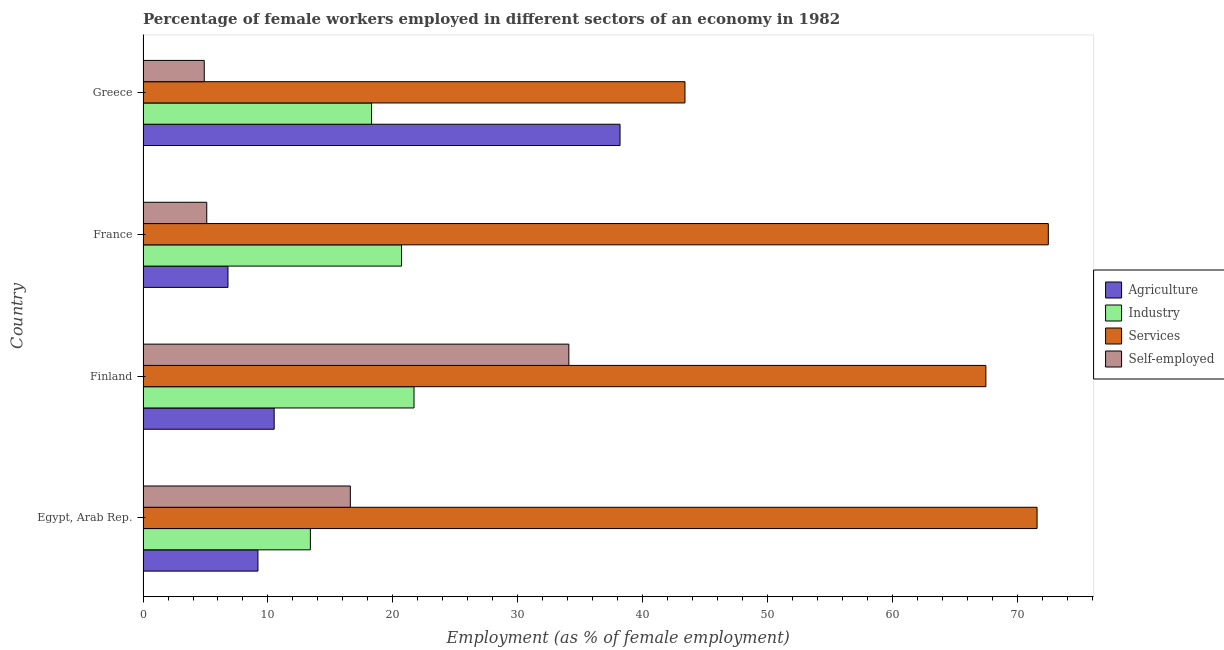How many bars are there on the 2nd tick from the top?
Provide a short and direct response. 4. How many bars are there on the 1st tick from the bottom?
Keep it short and to the point. 4. What is the label of the 3rd group of bars from the top?
Ensure brevity in your answer.  Finland. In how many cases, is the number of bars for a given country not equal to the number of legend labels?
Offer a terse response. 0. What is the percentage of female workers in agriculture in Greece?
Your response must be concise. 38.2. Across all countries, what is the maximum percentage of female workers in industry?
Your answer should be very brief. 21.7. Across all countries, what is the minimum percentage of female workers in services?
Offer a very short reply. 43.4. In which country was the percentage of female workers in services maximum?
Provide a succinct answer. France. What is the total percentage of female workers in industry in the graph?
Make the answer very short. 74.1. What is the difference between the percentage of female workers in industry in Greece and the percentage of female workers in services in France?
Your answer should be compact. -54.2. What is the average percentage of female workers in agriculture per country?
Your response must be concise. 16.18. What is the difference between the percentage of female workers in services and percentage of self employed female workers in Greece?
Make the answer very short. 38.5. What is the ratio of the percentage of female workers in agriculture in Egypt, Arab Rep. to that in Greece?
Give a very brief answer. 0.24. Is the difference between the percentage of female workers in services in Egypt, Arab Rep. and Greece greater than the difference between the percentage of female workers in agriculture in Egypt, Arab Rep. and Greece?
Your answer should be compact. Yes. What is the difference between the highest and the lowest percentage of female workers in industry?
Give a very brief answer. 8.3. Is the sum of the percentage of female workers in agriculture in France and Greece greater than the maximum percentage of female workers in industry across all countries?
Your response must be concise. Yes. What does the 4th bar from the top in Egypt, Arab Rep. represents?
Your response must be concise. Agriculture. What does the 3rd bar from the bottom in Greece represents?
Your answer should be compact. Services. Are all the bars in the graph horizontal?
Your response must be concise. Yes. How many countries are there in the graph?
Your response must be concise. 4. Does the graph contain grids?
Your answer should be very brief. No. What is the title of the graph?
Keep it short and to the point. Percentage of female workers employed in different sectors of an economy in 1982. Does "Primary schools" appear as one of the legend labels in the graph?
Your answer should be very brief. No. What is the label or title of the X-axis?
Ensure brevity in your answer.  Employment (as % of female employment). What is the Employment (as % of female employment) in Agriculture in Egypt, Arab Rep.?
Provide a succinct answer. 9.2. What is the Employment (as % of female employment) of Industry in Egypt, Arab Rep.?
Give a very brief answer. 13.4. What is the Employment (as % of female employment) in Services in Egypt, Arab Rep.?
Your response must be concise. 71.6. What is the Employment (as % of female employment) of Self-employed in Egypt, Arab Rep.?
Ensure brevity in your answer.  16.6. What is the Employment (as % of female employment) in Agriculture in Finland?
Keep it short and to the point. 10.5. What is the Employment (as % of female employment) in Industry in Finland?
Your answer should be compact. 21.7. What is the Employment (as % of female employment) of Services in Finland?
Ensure brevity in your answer.  67.5. What is the Employment (as % of female employment) in Self-employed in Finland?
Your answer should be compact. 34.1. What is the Employment (as % of female employment) of Agriculture in France?
Make the answer very short. 6.8. What is the Employment (as % of female employment) in Industry in France?
Offer a terse response. 20.7. What is the Employment (as % of female employment) of Services in France?
Your response must be concise. 72.5. What is the Employment (as % of female employment) of Self-employed in France?
Keep it short and to the point. 5.1. What is the Employment (as % of female employment) of Agriculture in Greece?
Provide a succinct answer. 38.2. What is the Employment (as % of female employment) of Industry in Greece?
Offer a terse response. 18.3. What is the Employment (as % of female employment) in Services in Greece?
Your answer should be very brief. 43.4. What is the Employment (as % of female employment) in Self-employed in Greece?
Ensure brevity in your answer.  4.9. Across all countries, what is the maximum Employment (as % of female employment) in Agriculture?
Provide a short and direct response. 38.2. Across all countries, what is the maximum Employment (as % of female employment) of Industry?
Make the answer very short. 21.7. Across all countries, what is the maximum Employment (as % of female employment) of Services?
Offer a very short reply. 72.5. Across all countries, what is the maximum Employment (as % of female employment) of Self-employed?
Your answer should be very brief. 34.1. Across all countries, what is the minimum Employment (as % of female employment) of Agriculture?
Offer a terse response. 6.8. Across all countries, what is the minimum Employment (as % of female employment) of Industry?
Provide a succinct answer. 13.4. Across all countries, what is the minimum Employment (as % of female employment) of Services?
Provide a short and direct response. 43.4. Across all countries, what is the minimum Employment (as % of female employment) of Self-employed?
Your response must be concise. 4.9. What is the total Employment (as % of female employment) of Agriculture in the graph?
Make the answer very short. 64.7. What is the total Employment (as % of female employment) in Industry in the graph?
Provide a succinct answer. 74.1. What is the total Employment (as % of female employment) in Services in the graph?
Provide a succinct answer. 255. What is the total Employment (as % of female employment) of Self-employed in the graph?
Keep it short and to the point. 60.7. What is the difference between the Employment (as % of female employment) in Self-employed in Egypt, Arab Rep. and that in Finland?
Offer a terse response. -17.5. What is the difference between the Employment (as % of female employment) in Agriculture in Egypt, Arab Rep. and that in France?
Provide a short and direct response. 2.4. What is the difference between the Employment (as % of female employment) of Services in Egypt, Arab Rep. and that in France?
Give a very brief answer. -0.9. What is the difference between the Employment (as % of female employment) of Services in Egypt, Arab Rep. and that in Greece?
Your response must be concise. 28.2. What is the difference between the Employment (as % of female employment) in Agriculture in Finland and that in France?
Your answer should be very brief. 3.7. What is the difference between the Employment (as % of female employment) of Industry in Finland and that in France?
Make the answer very short. 1. What is the difference between the Employment (as % of female employment) in Services in Finland and that in France?
Provide a succinct answer. -5. What is the difference between the Employment (as % of female employment) in Agriculture in Finland and that in Greece?
Your response must be concise. -27.7. What is the difference between the Employment (as % of female employment) in Industry in Finland and that in Greece?
Ensure brevity in your answer.  3.4. What is the difference between the Employment (as % of female employment) in Services in Finland and that in Greece?
Offer a very short reply. 24.1. What is the difference between the Employment (as % of female employment) in Self-employed in Finland and that in Greece?
Your answer should be compact. 29.2. What is the difference between the Employment (as % of female employment) in Agriculture in France and that in Greece?
Offer a very short reply. -31.4. What is the difference between the Employment (as % of female employment) of Services in France and that in Greece?
Your response must be concise. 29.1. What is the difference between the Employment (as % of female employment) of Agriculture in Egypt, Arab Rep. and the Employment (as % of female employment) of Services in Finland?
Make the answer very short. -58.3. What is the difference between the Employment (as % of female employment) in Agriculture in Egypt, Arab Rep. and the Employment (as % of female employment) in Self-employed in Finland?
Make the answer very short. -24.9. What is the difference between the Employment (as % of female employment) of Industry in Egypt, Arab Rep. and the Employment (as % of female employment) of Services in Finland?
Offer a very short reply. -54.1. What is the difference between the Employment (as % of female employment) in Industry in Egypt, Arab Rep. and the Employment (as % of female employment) in Self-employed in Finland?
Ensure brevity in your answer.  -20.7. What is the difference between the Employment (as % of female employment) of Services in Egypt, Arab Rep. and the Employment (as % of female employment) of Self-employed in Finland?
Offer a terse response. 37.5. What is the difference between the Employment (as % of female employment) of Agriculture in Egypt, Arab Rep. and the Employment (as % of female employment) of Industry in France?
Offer a terse response. -11.5. What is the difference between the Employment (as % of female employment) in Agriculture in Egypt, Arab Rep. and the Employment (as % of female employment) in Services in France?
Provide a succinct answer. -63.3. What is the difference between the Employment (as % of female employment) of Industry in Egypt, Arab Rep. and the Employment (as % of female employment) of Services in France?
Provide a succinct answer. -59.1. What is the difference between the Employment (as % of female employment) of Industry in Egypt, Arab Rep. and the Employment (as % of female employment) of Self-employed in France?
Offer a terse response. 8.3. What is the difference between the Employment (as % of female employment) in Services in Egypt, Arab Rep. and the Employment (as % of female employment) in Self-employed in France?
Your answer should be very brief. 66.5. What is the difference between the Employment (as % of female employment) in Agriculture in Egypt, Arab Rep. and the Employment (as % of female employment) in Industry in Greece?
Your answer should be compact. -9.1. What is the difference between the Employment (as % of female employment) in Agriculture in Egypt, Arab Rep. and the Employment (as % of female employment) in Services in Greece?
Your answer should be very brief. -34.2. What is the difference between the Employment (as % of female employment) in Industry in Egypt, Arab Rep. and the Employment (as % of female employment) in Self-employed in Greece?
Offer a terse response. 8.5. What is the difference between the Employment (as % of female employment) of Services in Egypt, Arab Rep. and the Employment (as % of female employment) of Self-employed in Greece?
Give a very brief answer. 66.7. What is the difference between the Employment (as % of female employment) of Agriculture in Finland and the Employment (as % of female employment) of Services in France?
Give a very brief answer. -62. What is the difference between the Employment (as % of female employment) in Industry in Finland and the Employment (as % of female employment) in Services in France?
Give a very brief answer. -50.8. What is the difference between the Employment (as % of female employment) of Services in Finland and the Employment (as % of female employment) of Self-employed in France?
Your response must be concise. 62.4. What is the difference between the Employment (as % of female employment) in Agriculture in Finland and the Employment (as % of female employment) in Services in Greece?
Keep it short and to the point. -32.9. What is the difference between the Employment (as % of female employment) of Agriculture in Finland and the Employment (as % of female employment) of Self-employed in Greece?
Your answer should be compact. 5.6. What is the difference between the Employment (as % of female employment) in Industry in Finland and the Employment (as % of female employment) in Services in Greece?
Offer a terse response. -21.7. What is the difference between the Employment (as % of female employment) of Industry in Finland and the Employment (as % of female employment) of Self-employed in Greece?
Your answer should be very brief. 16.8. What is the difference between the Employment (as % of female employment) of Services in Finland and the Employment (as % of female employment) of Self-employed in Greece?
Make the answer very short. 62.6. What is the difference between the Employment (as % of female employment) of Agriculture in France and the Employment (as % of female employment) of Services in Greece?
Offer a very short reply. -36.6. What is the difference between the Employment (as % of female employment) in Agriculture in France and the Employment (as % of female employment) in Self-employed in Greece?
Ensure brevity in your answer.  1.9. What is the difference between the Employment (as % of female employment) of Industry in France and the Employment (as % of female employment) of Services in Greece?
Your answer should be compact. -22.7. What is the difference between the Employment (as % of female employment) of Services in France and the Employment (as % of female employment) of Self-employed in Greece?
Provide a succinct answer. 67.6. What is the average Employment (as % of female employment) of Agriculture per country?
Offer a very short reply. 16.18. What is the average Employment (as % of female employment) of Industry per country?
Provide a succinct answer. 18.52. What is the average Employment (as % of female employment) of Services per country?
Your answer should be very brief. 63.75. What is the average Employment (as % of female employment) in Self-employed per country?
Make the answer very short. 15.18. What is the difference between the Employment (as % of female employment) in Agriculture and Employment (as % of female employment) in Services in Egypt, Arab Rep.?
Give a very brief answer. -62.4. What is the difference between the Employment (as % of female employment) of Industry and Employment (as % of female employment) of Services in Egypt, Arab Rep.?
Your response must be concise. -58.2. What is the difference between the Employment (as % of female employment) in Agriculture and Employment (as % of female employment) in Industry in Finland?
Ensure brevity in your answer.  -11.2. What is the difference between the Employment (as % of female employment) in Agriculture and Employment (as % of female employment) in Services in Finland?
Your answer should be very brief. -57. What is the difference between the Employment (as % of female employment) of Agriculture and Employment (as % of female employment) of Self-employed in Finland?
Make the answer very short. -23.6. What is the difference between the Employment (as % of female employment) in Industry and Employment (as % of female employment) in Services in Finland?
Offer a very short reply. -45.8. What is the difference between the Employment (as % of female employment) of Industry and Employment (as % of female employment) of Self-employed in Finland?
Provide a succinct answer. -12.4. What is the difference between the Employment (as % of female employment) in Services and Employment (as % of female employment) in Self-employed in Finland?
Your response must be concise. 33.4. What is the difference between the Employment (as % of female employment) in Agriculture and Employment (as % of female employment) in Industry in France?
Provide a short and direct response. -13.9. What is the difference between the Employment (as % of female employment) of Agriculture and Employment (as % of female employment) of Services in France?
Ensure brevity in your answer.  -65.7. What is the difference between the Employment (as % of female employment) of Agriculture and Employment (as % of female employment) of Self-employed in France?
Ensure brevity in your answer.  1.7. What is the difference between the Employment (as % of female employment) in Industry and Employment (as % of female employment) in Services in France?
Ensure brevity in your answer.  -51.8. What is the difference between the Employment (as % of female employment) in Industry and Employment (as % of female employment) in Self-employed in France?
Ensure brevity in your answer.  15.6. What is the difference between the Employment (as % of female employment) of Services and Employment (as % of female employment) of Self-employed in France?
Provide a short and direct response. 67.4. What is the difference between the Employment (as % of female employment) of Agriculture and Employment (as % of female employment) of Services in Greece?
Keep it short and to the point. -5.2. What is the difference between the Employment (as % of female employment) of Agriculture and Employment (as % of female employment) of Self-employed in Greece?
Offer a terse response. 33.3. What is the difference between the Employment (as % of female employment) in Industry and Employment (as % of female employment) in Services in Greece?
Your answer should be compact. -25.1. What is the difference between the Employment (as % of female employment) in Services and Employment (as % of female employment) in Self-employed in Greece?
Make the answer very short. 38.5. What is the ratio of the Employment (as % of female employment) of Agriculture in Egypt, Arab Rep. to that in Finland?
Your answer should be very brief. 0.88. What is the ratio of the Employment (as % of female employment) in Industry in Egypt, Arab Rep. to that in Finland?
Offer a very short reply. 0.62. What is the ratio of the Employment (as % of female employment) in Services in Egypt, Arab Rep. to that in Finland?
Your response must be concise. 1.06. What is the ratio of the Employment (as % of female employment) of Self-employed in Egypt, Arab Rep. to that in Finland?
Provide a short and direct response. 0.49. What is the ratio of the Employment (as % of female employment) of Agriculture in Egypt, Arab Rep. to that in France?
Ensure brevity in your answer.  1.35. What is the ratio of the Employment (as % of female employment) in Industry in Egypt, Arab Rep. to that in France?
Keep it short and to the point. 0.65. What is the ratio of the Employment (as % of female employment) of Services in Egypt, Arab Rep. to that in France?
Keep it short and to the point. 0.99. What is the ratio of the Employment (as % of female employment) in Self-employed in Egypt, Arab Rep. to that in France?
Your answer should be very brief. 3.25. What is the ratio of the Employment (as % of female employment) in Agriculture in Egypt, Arab Rep. to that in Greece?
Offer a very short reply. 0.24. What is the ratio of the Employment (as % of female employment) of Industry in Egypt, Arab Rep. to that in Greece?
Your answer should be compact. 0.73. What is the ratio of the Employment (as % of female employment) in Services in Egypt, Arab Rep. to that in Greece?
Give a very brief answer. 1.65. What is the ratio of the Employment (as % of female employment) of Self-employed in Egypt, Arab Rep. to that in Greece?
Provide a short and direct response. 3.39. What is the ratio of the Employment (as % of female employment) of Agriculture in Finland to that in France?
Ensure brevity in your answer.  1.54. What is the ratio of the Employment (as % of female employment) of Industry in Finland to that in France?
Ensure brevity in your answer.  1.05. What is the ratio of the Employment (as % of female employment) of Self-employed in Finland to that in France?
Give a very brief answer. 6.69. What is the ratio of the Employment (as % of female employment) in Agriculture in Finland to that in Greece?
Your answer should be very brief. 0.27. What is the ratio of the Employment (as % of female employment) of Industry in Finland to that in Greece?
Offer a terse response. 1.19. What is the ratio of the Employment (as % of female employment) in Services in Finland to that in Greece?
Keep it short and to the point. 1.56. What is the ratio of the Employment (as % of female employment) in Self-employed in Finland to that in Greece?
Offer a terse response. 6.96. What is the ratio of the Employment (as % of female employment) of Agriculture in France to that in Greece?
Your answer should be compact. 0.18. What is the ratio of the Employment (as % of female employment) of Industry in France to that in Greece?
Give a very brief answer. 1.13. What is the ratio of the Employment (as % of female employment) in Services in France to that in Greece?
Offer a very short reply. 1.67. What is the ratio of the Employment (as % of female employment) in Self-employed in France to that in Greece?
Your answer should be very brief. 1.04. What is the difference between the highest and the second highest Employment (as % of female employment) in Agriculture?
Your answer should be very brief. 27.7. What is the difference between the highest and the second highest Employment (as % of female employment) in Industry?
Your answer should be very brief. 1. What is the difference between the highest and the lowest Employment (as % of female employment) of Agriculture?
Offer a very short reply. 31.4. What is the difference between the highest and the lowest Employment (as % of female employment) of Services?
Provide a short and direct response. 29.1. What is the difference between the highest and the lowest Employment (as % of female employment) in Self-employed?
Your answer should be very brief. 29.2. 